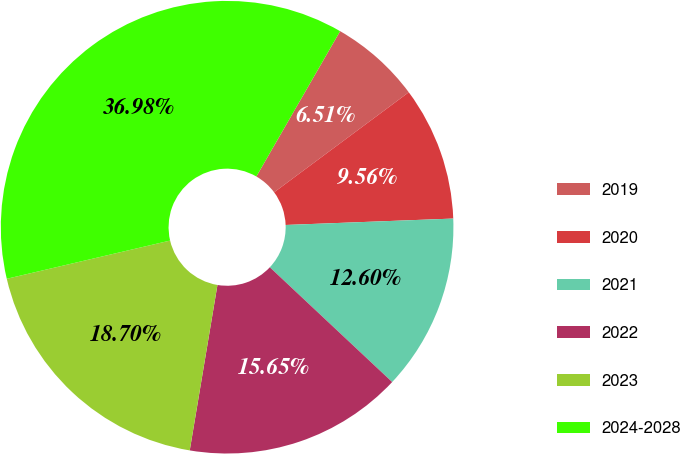Convert chart. <chart><loc_0><loc_0><loc_500><loc_500><pie_chart><fcel>2019<fcel>2020<fcel>2021<fcel>2022<fcel>2023<fcel>2024-2028<nl><fcel>6.51%<fcel>9.56%<fcel>12.6%<fcel>15.65%<fcel>18.7%<fcel>36.98%<nl></chart> 